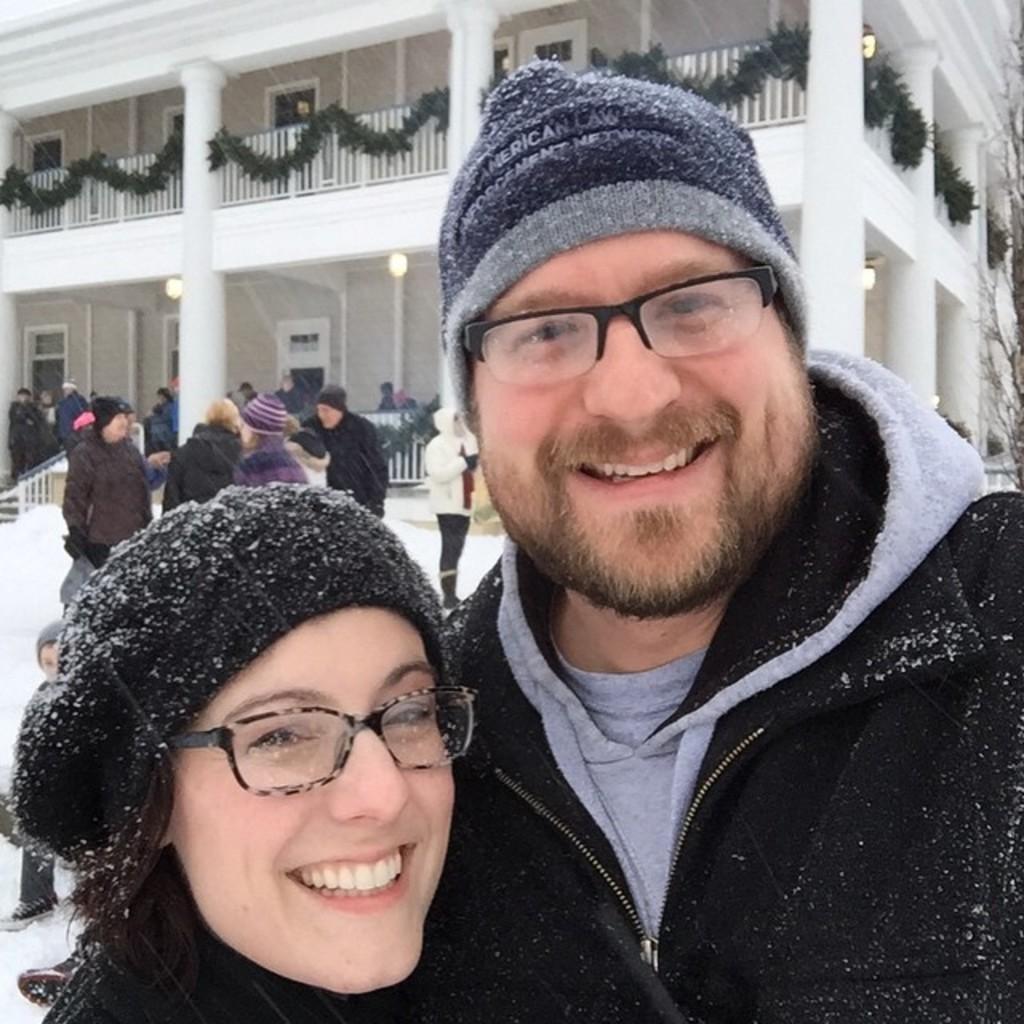Could you give a brief overview of what you see in this image? In the given image i can see a people,building with windows,lights and fence. 